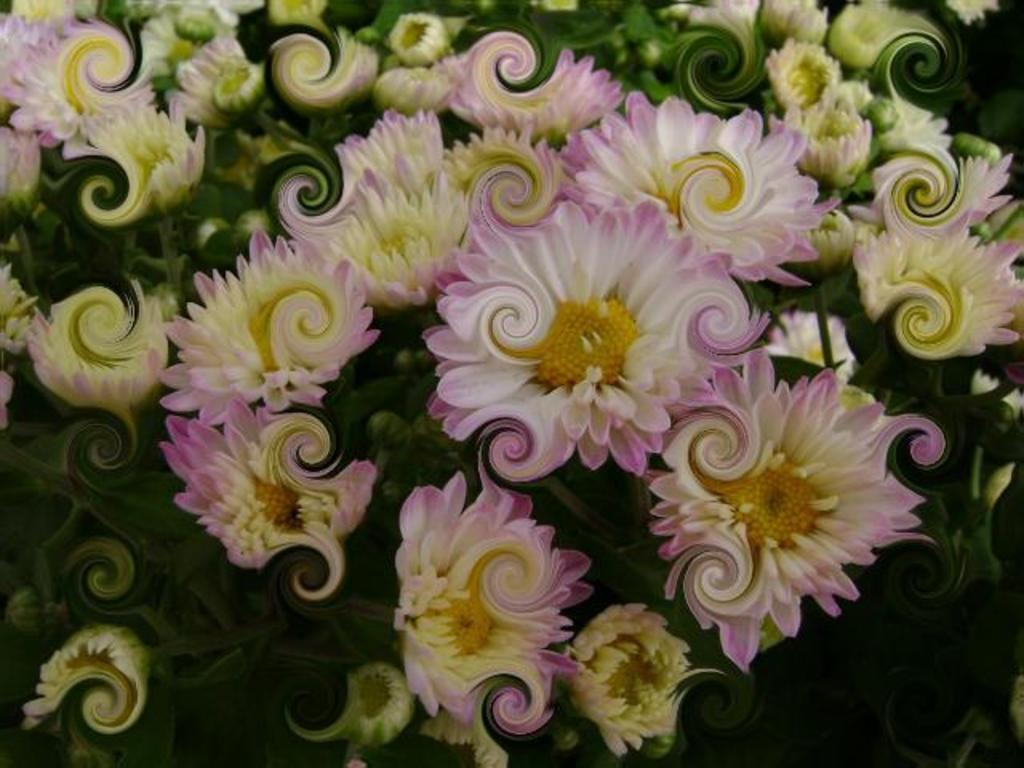What type of flora can be seen in the image? There are flowers in the image. What colors are the flowers? The flowers are cream, pink, and yellow in color. What other natural elements are present in the image? There are trees in the image. What color are the trees? The trees are green in color. How many snails can be seen crawling on the flowers in the image? There are no snails visible in the image; it only features flowers and trees. What type of birds can be seen flying around the trees in the image? There are no birds present in the image; it only features flowers and trees. 